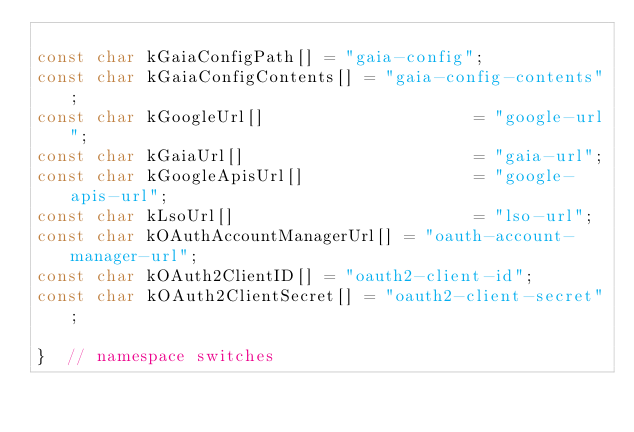Convert code to text. <code><loc_0><loc_0><loc_500><loc_500><_C++_>
const char kGaiaConfigPath[] = "gaia-config";
const char kGaiaConfigContents[] = "gaia-config-contents";
const char kGoogleUrl[]                     = "google-url";
const char kGaiaUrl[]                       = "gaia-url";
const char kGoogleApisUrl[]                 = "google-apis-url";
const char kLsoUrl[]                        = "lso-url";
const char kOAuthAccountManagerUrl[] = "oauth-account-manager-url";
const char kOAuth2ClientID[] = "oauth2-client-id";
const char kOAuth2ClientSecret[] = "oauth2-client-secret";

}  // namespace switches
</code> 